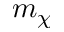Convert formula to latex. <formula><loc_0><loc_0><loc_500><loc_500>m _ { \chi }</formula> 